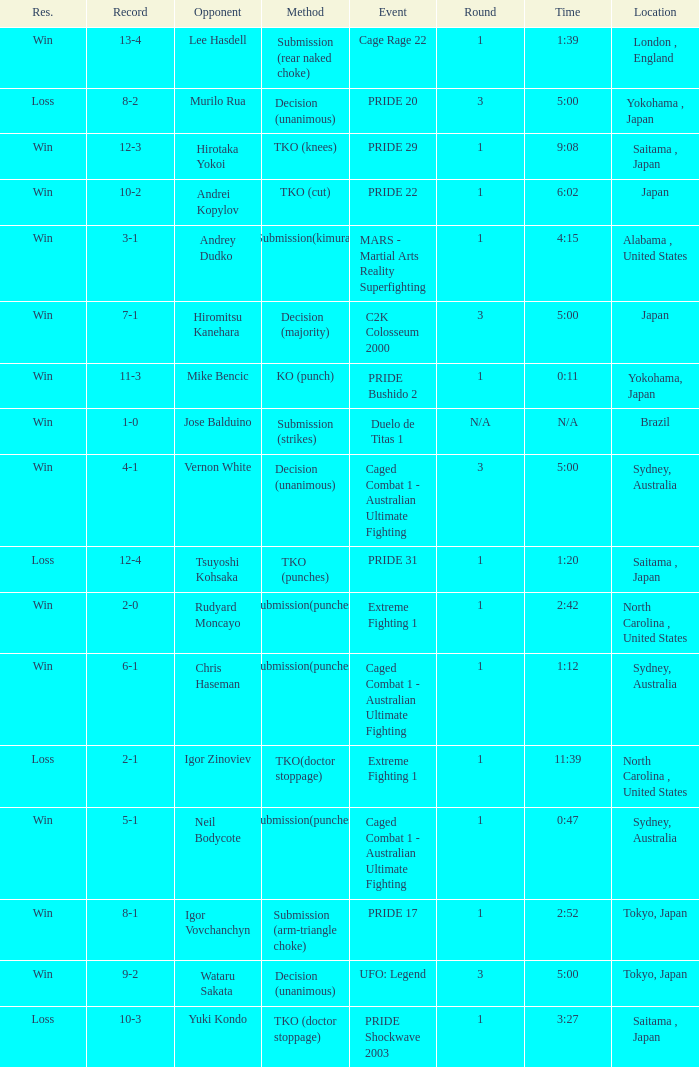Which Record has the Res of win with the Event of extreme fighting 1? 2-0. Would you be able to parse every entry in this table? {'header': ['Res.', 'Record', 'Opponent', 'Method', 'Event', 'Round', 'Time', 'Location'], 'rows': [['Win', '13-4', 'Lee Hasdell', 'Submission (rear naked choke)', 'Cage Rage 22', '1', '1:39', 'London , England'], ['Loss', '8-2', 'Murilo Rua', 'Decision (unanimous)', 'PRIDE 20', '3', '5:00', 'Yokohama , Japan'], ['Win', '12-3', 'Hirotaka Yokoi', 'TKO (knees)', 'PRIDE 29', '1', '9:08', 'Saitama , Japan'], ['Win', '10-2', 'Andrei Kopylov', 'TKO (cut)', 'PRIDE 22', '1', '6:02', 'Japan'], ['Win', '3-1', 'Andrey Dudko', 'Submission(kimura)', 'MARS - Martial Arts Reality Superfighting', '1', '4:15', 'Alabama , United States'], ['Win', '7-1', 'Hiromitsu Kanehara', 'Decision (majority)', 'C2K Colosseum 2000', '3', '5:00', 'Japan'], ['Win', '11-3', 'Mike Bencic', 'KO (punch)', 'PRIDE Bushido 2', '1', '0:11', 'Yokohama, Japan'], ['Win', '1-0', 'Jose Balduino', 'Submission (strikes)', 'Duelo de Titas 1', 'N/A', 'N/A', 'Brazil'], ['Win', '4-1', 'Vernon White', 'Decision (unanimous)', 'Caged Combat 1 - Australian Ultimate Fighting', '3', '5:00', 'Sydney, Australia'], ['Loss', '12-4', 'Tsuyoshi Kohsaka', 'TKO (punches)', 'PRIDE 31', '1', '1:20', 'Saitama , Japan'], ['Win', '2-0', 'Rudyard Moncayo', 'Submission(punches)', 'Extreme Fighting 1', '1', '2:42', 'North Carolina , United States'], ['Win', '6-1', 'Chris Haseman', 'Submission(punches)', 'Caged Combat 1 - Australian Ultimate Fighting', '1', '1:12', 'Sydney, Australia'], ['Loss', '2-1', 'Igor Zinoviev', 'TKO(doctor stoppage)', 'Extreme Fighting 1', '1', '11:39', 'North Carolina , United States'], ['Win', '5-1', 'Neil Bodycote', 'Submission(punches)', 'Caged Combat 1 - Australian Ultimate Fighting', '1', '0:47', 'Sydney, Australia'], ['Win', '8-1', 'Igor Vovchanchyn', 'Submission (arm-triangle choke)', 'PRIDE 17', '1', '2:52', 'Tokyo, Japan'], ['Win', '9-2', 'Wataru Sakata', 'Decision (unanimous)', 'UFO: Legend', '3', '5:00', 'Tokyo, Japan'], ['Loss', '10-3', 'Yuki Kondo', 'TKO (doctor stoppage)', 'PRIDE Shockwave 2003', '1', '3:27', 'Saitama , Japan']]} 